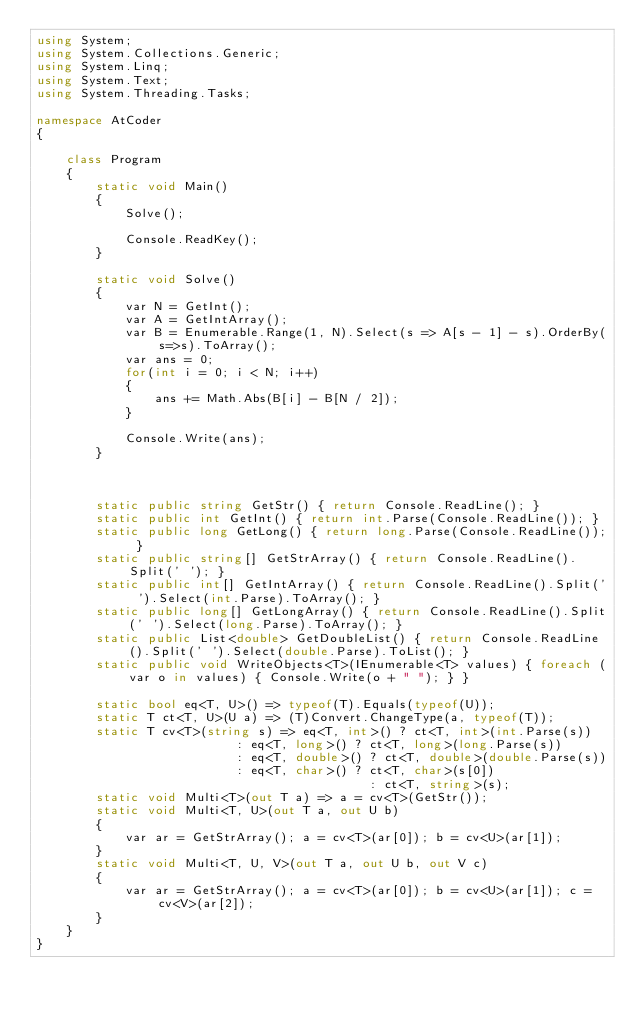Convert code to text. <code><loc_0><loc_0><loc_500><loc_500><_C#_>using System;
using System.Collections.Generic;
using System.Linq;
using System.Text;
using System.Threading.Tasks;

namespace AtCoder
{

    class Program
    {
        static void Main()
        {
            Solve();

            Console.ReadKey();
        }

        static void Solve()
        {
            var N = GetInt();
            var A = GetIntArray();
            var B = Enumerable.Range(1, N).Select(s => A[s - 1] - s).OrderBy(s=>s).ToArray();
            var ans = 0;
            for(int i = 0; i < N; i++)
            {
                ans += Math.Abs(B[i] - B[N / 2]);
            }

            Console.Write(ans);
        }



        static public string GetStr() { return Console.ReadLine(); }
        static public int GetInt() { return int.Parse(Console.ReadLine()); }
        static public long GetLong() { return long.Parse(Console.ReadLine()); }
        static public string[] GetStrArray() { return Console.ReadLine().Split(' '); }
        static public int[] GetIntArray() { return Console.ReadLine().Split(' ').Select(int.Parse).ToArray(); }
        static public long[] GetLongArray() { return Console.ReadLine().Split(' ').Select(long.Parse).ToArray(); }
        static public List<double> GetDoubleList() { return Console.ReadLine().Split(' ').Select(double.Parse).ToList(); }
        static public void WriteObjects<T>(IEnumerable<T> values) { foreach (var o in values) { Console.Write(o + " "); } }

        static bool eq<T, U>() => typeof(T).Equals(typeof(U));
        static T ct<T, U>(U a) => (T)Convert.ChangeType(a, typeof(T));
        static T cv<T>(string s) => eq<T, int>() ? ct<T, int>(int.Parse(s))
                           : eq<T, long>() ? ct<T, long>(long.Parse(s))
                           : eq<T, double>() ? ct<T, double>(double.Parse(s))
                           : eq<T, char>() ? ct<T, char>(s[0])
                                             : ct<T, string>(s);
        static void Multi<T>(out T a) => a = cv<T>(GetStr());
        static void Multi<T, U>(out T a, out U b)
        {
            var ar = GetStrArray(); a = cv<T>(ar[0]); b = cv<U>(ar[1]);
        }
        static void Multi<T, U, V>(out T a, out U b, out V c)
        {
            var ar = GetStrArray(); a = cv<T>(ar[0]); b = cv<U>(ar[1]); c = cv<V>(ar[2]);
        }
    }
}</code> 